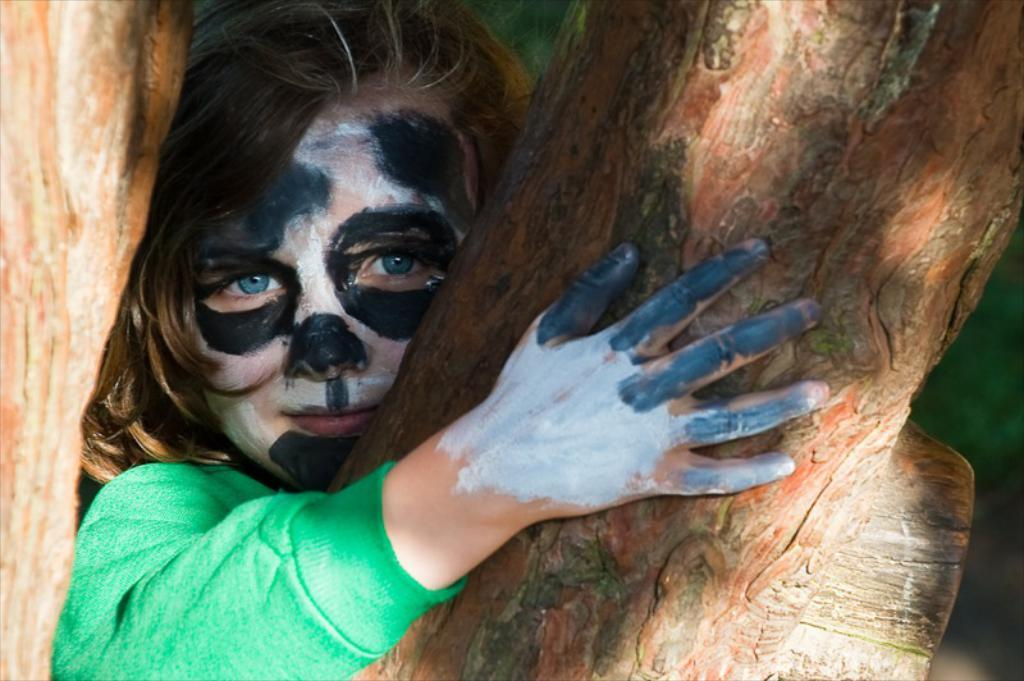Who is the main subject in the image? There is a girl in the image. What is the girl holding in the image? The girl is holding a tree branch. What type of vest is the girl wearing in the image? There is no vest visible in the image; the girl is holding a tree branch. 